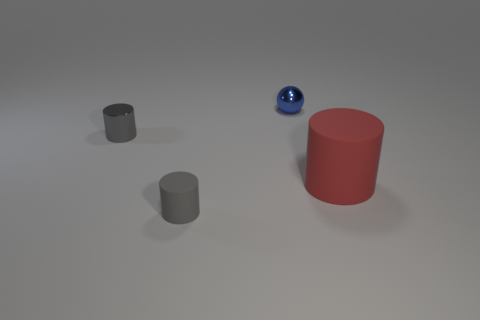Add 3 tiny metal balls. How many objects exist? 7 Subtract all cylinders. How many objects are left? 1 Subtract 0 brown cubes. How many objects are left? 4 Subtract all gray objects. Subtract all large cylinders. How many objects are left? 1 Add 2 blue metal things. How many blue metal things are left? 3 Add 3 small red metal blocks. How many small red metal blocks exist? 3 